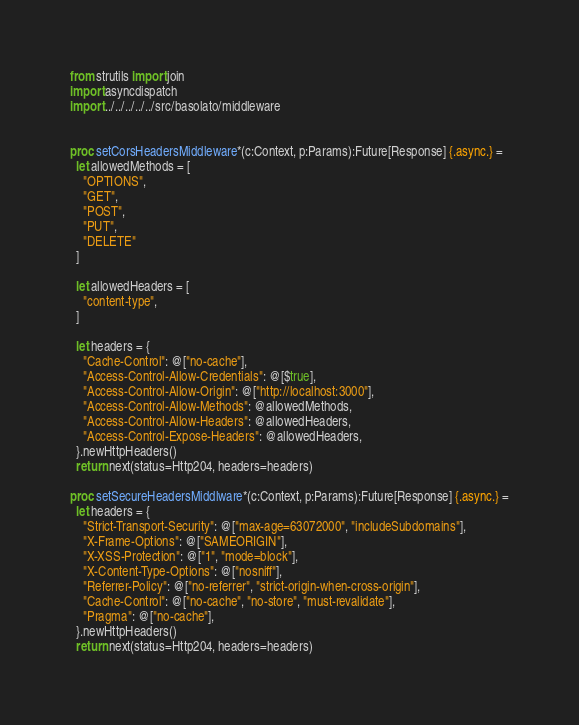Convert code to text. <code><loc_0><loc_0><loc_500><loc_500><_Nim_>from strutils import join
import asyncdispatch
import ../../../../../src/basolato/middleware


proc setCorsHeadersMiddleware*(c:Context, p:Params):Future[Response] {.async.} =
  let allowedMethods = [
    "OPTIONS",
    "GET",
    "POST",
    "PUT",
    "DELETE"
  ]

  let allowedHeaders = [
    "content-type",
  ]

  let headers = {
    "Cache-Control": @["no-cache"],
    "Access-Control-Allow-Credentials": @[$true],
    "Access-Control-Allow-Origin": @["http://localhost:3000"],
    "Access-Control-Allow-Methods": @allowedMethods,
    "Access-Control-Allow-Headers": @allowedHeaders,
    "Access-Control-Expose-Headers": @allowedHeaders,
  }.newHttpHeaders()
  return next(status=Http204, headers=headers)

proc setSecureHeadersMiddlware*(c:Context, p:Params):Future[Response] {.async.} =
  let headers = {
    "Strict-Transport-Security": @["max-age=63072000", "includeSubdomains"],
    "X-Frame-Options": @["SAMEORIGIN"],
    "X-XSS-Protection": @["1", "mode=block"],
    "X-Content-Type-Options": @["nosniff"],
    "Referrer-Policy": @["no-referrer", "strict-origin-when-cross-origin"],
    "Cache-Control": @["no-cache", "no-store", "must-revalidate"],
    "Pragma": @["no-cache"],
  }.newHttpHeaders()
  return next(status=Http204, headers=headers)
</code> 